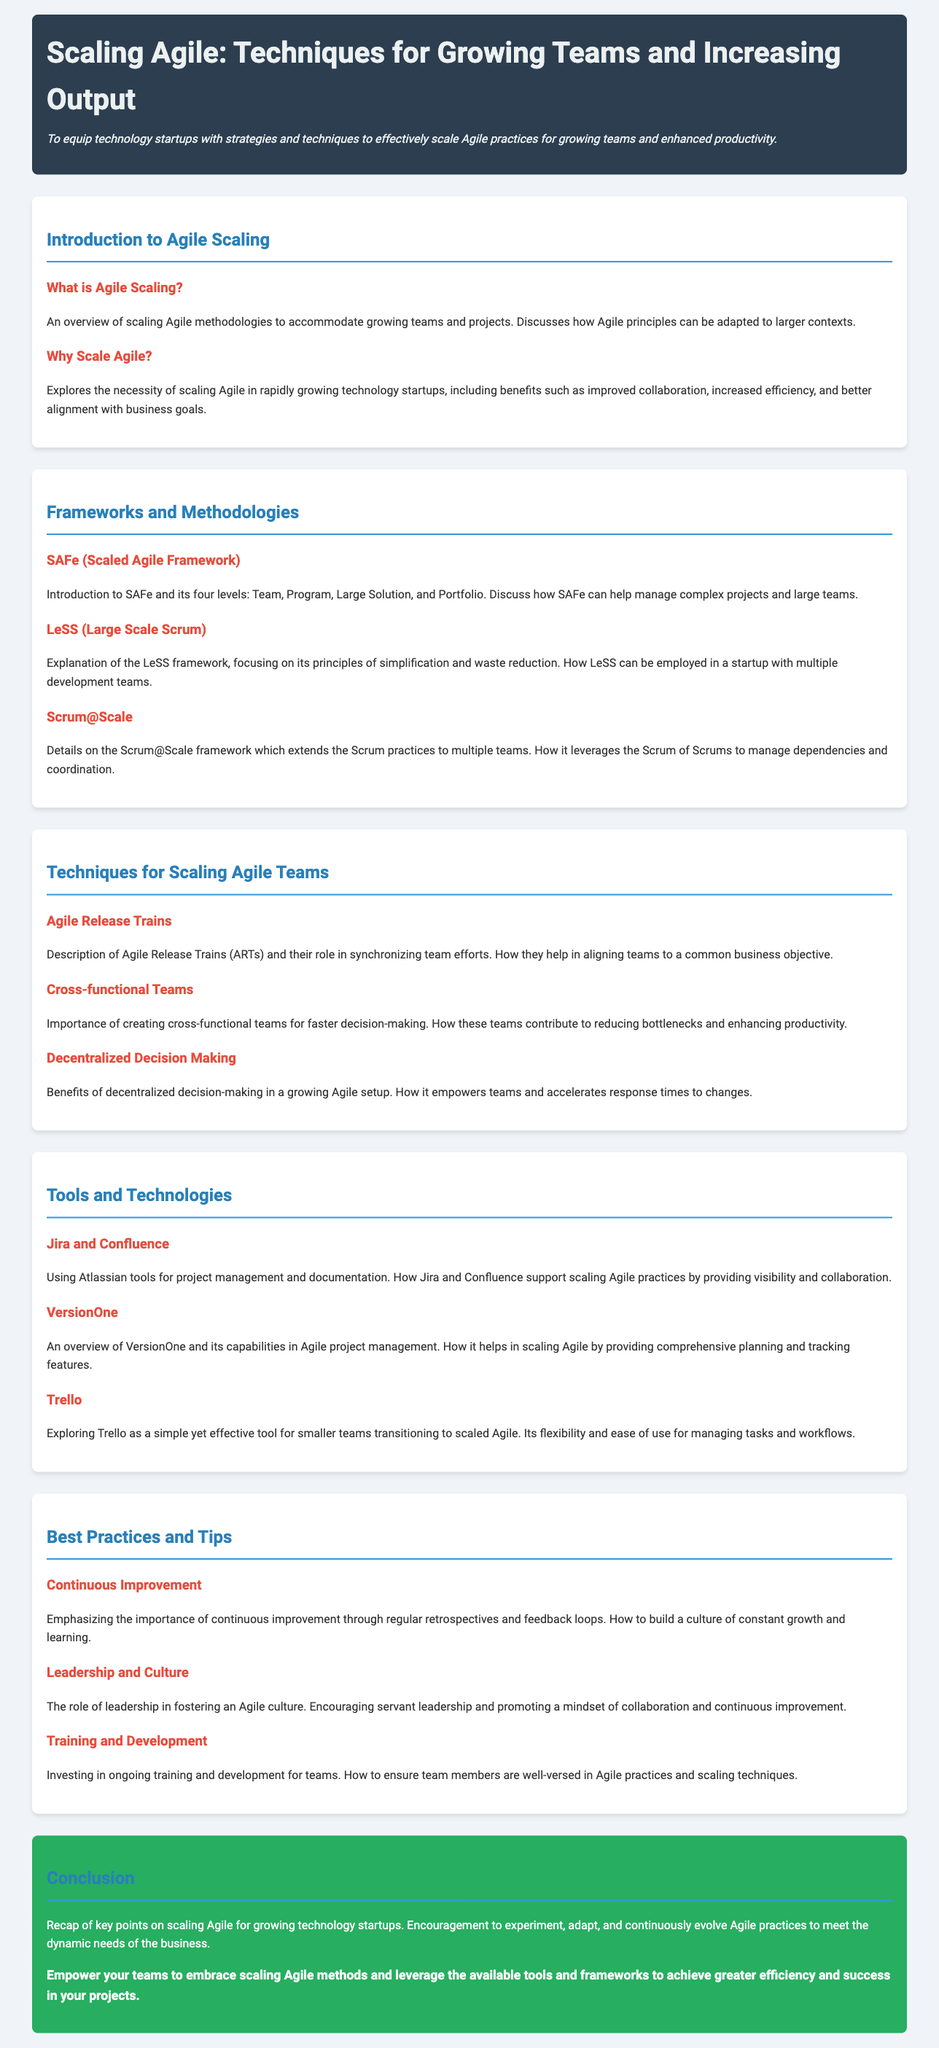What is the title of the lesson plan? The title of the lesson plan is provided at the beginning of the document.
Answer: Scaling Agile: Techniques for Growing Teams and Increasing Output What is the objective of the lesson plan? The objective explains the purpose of the lesson plan located under the title.
Answer: To equip technology startups with strategies and techniques to effectively scale Agile practices for growing teams and enhanced productivity What framework is introduced in the section about Scaling Agile? The section outlines different frameworks and one is specifically called out.
Answer: SAFe (Scaled Agile Framework) How many levels are in the SAFe framework? The introduction to SAFe mentions the number of levels within the framework.
Answer: Four What is the role of Agile Release Trains (ARTs)? The document explains the function of ARTs in synchronizing team efforts.
Answer: Synchronizing team efforts What does LeSS stand for? The document provides the abbreviation used in the context of Agile scaling frameworks.
Answer: Large Scale Scrum Name one tool mentioned for project management in the lesson plan. The tools and technologies section lists specific tools used in Agile project management.
Answer: Jira What is emphasized as a key practice for scaling Agile teams? The best practices section discusses continuous improvement as essential for scaling.
Answer: Continuous Improvement Who plays a crucial role in fostering an Agile culture? The document highlights an important factor in promoting Agile practices within teams.
Answer: Leadership 